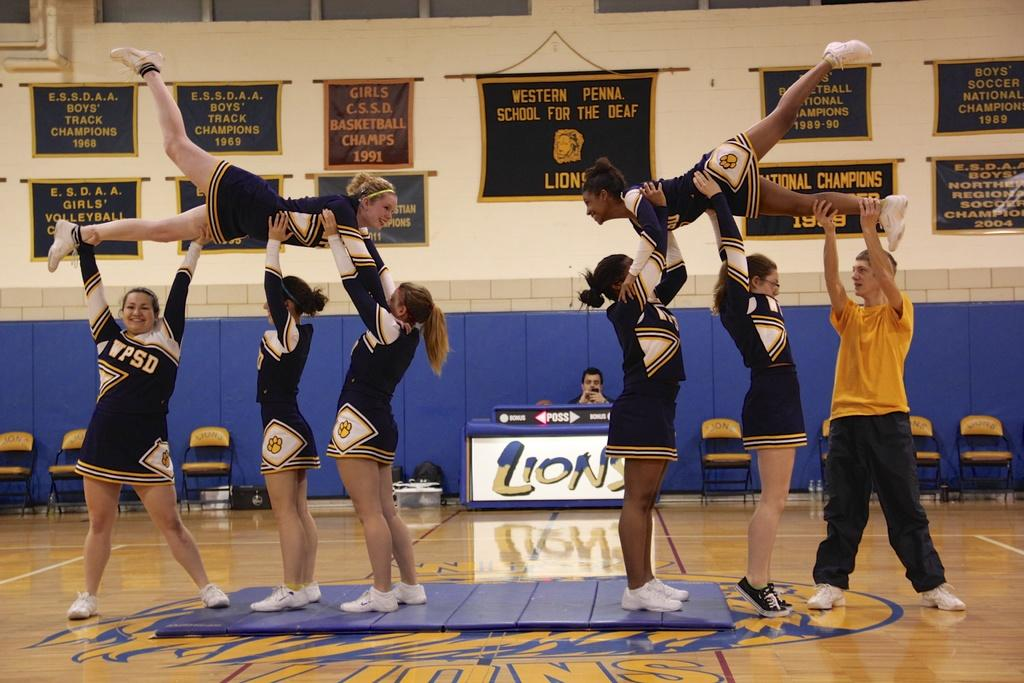<image>
Provide a brief description of the given image. Cheerleaders for the Lions, with the letters WPSD on their uniforms, are performing a stunt in the middle of a gym floor. 